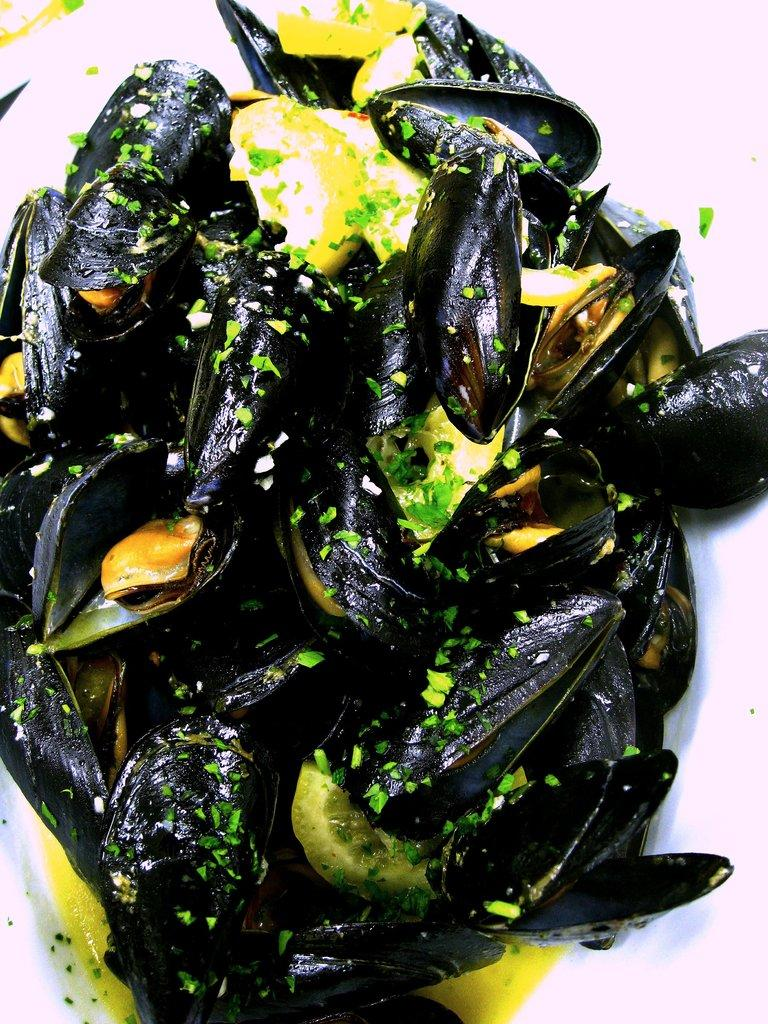What type of food item is present in the image? There is a food item called Mussel in the image. What is the view like from the Mussel in the image? The image does not provide any information about the view from the Mussel, as it is a static image of a food item. 